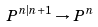Convert formula to latex. <formula><loc_0><loc_0><loc_500><loc_500>P ^ { n | n + 1 } \rightarrow P ^ { n }</formula> 